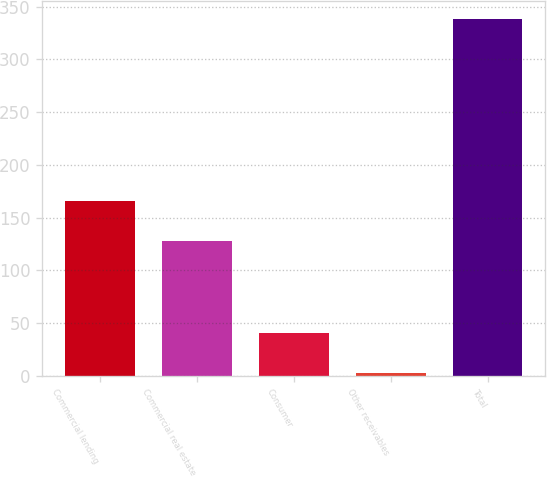<chart> <loc_0><loc_0><loc_500><loc_500><bar_chart><fcel>Commercial lending<fcel>Commercial real estate<fcel>Consumer<fcel>Other receivables<fcel>Total<nl><fcel>166<fcel>128<fcel>41<fcel>3<fcel>338<nl></chart> 